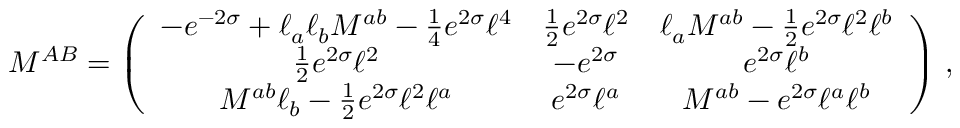<formula> <loc_0><loc_0><loc_500><loc_500>M ^ { A B } = \left ( \begin{array} { c c c } { { - e ^ { - 2 \sigma } + \ell _ { a } \ell _ { b } { M } ^ { a b } - \frac { 1 } { 4 } e ^ { 2 \sigma } { \ell } ^ { 4 } } } & { { \frac { 1 } { 2 } e ^ { 2 { \sigma } } { \ell } ^ { 2 } } } & { { { \ell } _ { a } { M } ^ { a b } - \frac { 1 } { 2 } e ^ { 2 { \sigma } } { \ell } ^ { 2 } { \ell } ^ { b } } } \\ { { \frac { 1 } { 2 } e ^ { 2 { \sigma } } { \ell } ^ { 2 } } } & { { - e ^ { 2 \sigma } } } & { { e ^ { 2 { \sigma } } { \ell } ^ { b } } } \\ { { { M } ^ { a b } { \ell } _ { b } - \frac { 1 } { 2 } e ^ { 2 { \sigma } } { \ell } ^ { 2 } { \ell } ^ { a } } } & { { e ^ { 2 { \sigma } } { \ell } ^ { a } } } & { { { M } ^ { a b } - e ^ { 2 \sigma } { \ell } ^ { a } { \ell } ^ { b } } } \end{array} \right ) \, ,</formula> 